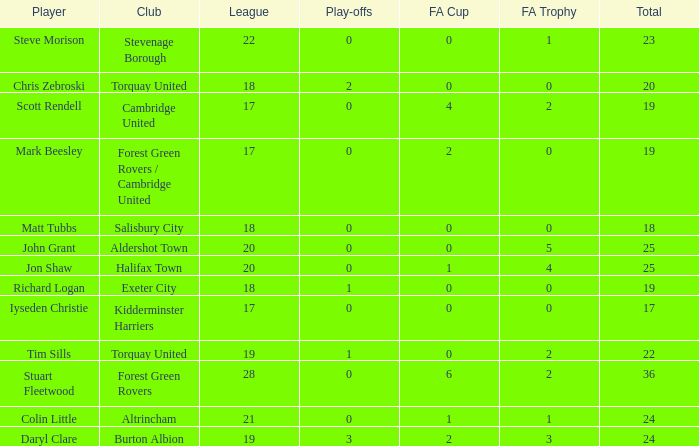Which mean total had Tim Sills as a player? 22.0. 